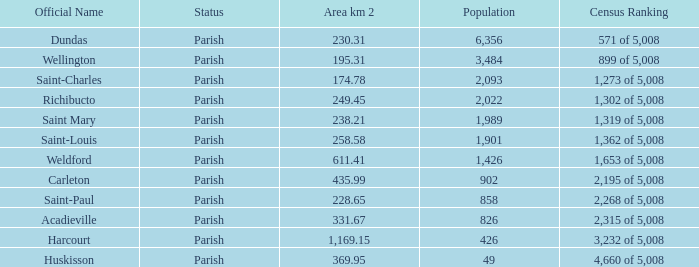If saint-paul parish covers an area exceeding 22 0.0. 